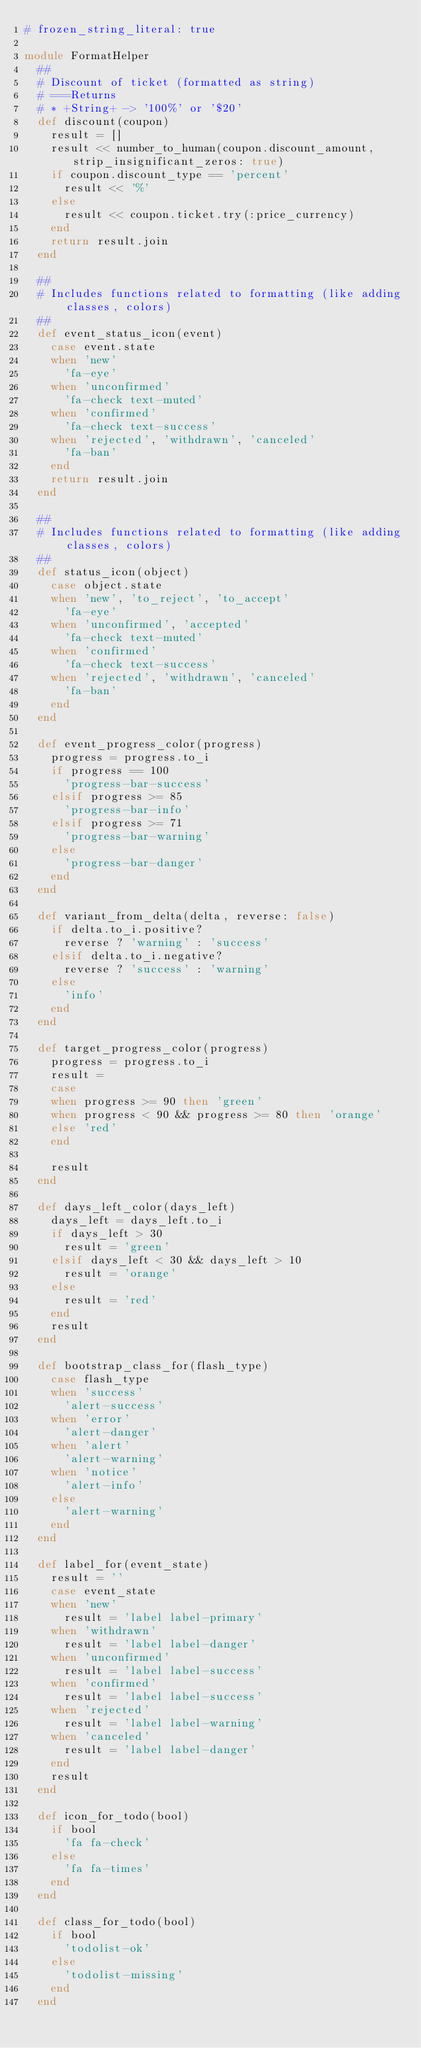<code> <loc_0><loc_0><loc_500><loc_500><_Ruby_># frozen_string_literal: true

module FormatHelper
  ##
  # Discount of ticket (formatted as string)
  # ===Returns
  # * +String+ -> '100%' or '$20'
  def discount(coupon)
    result = []
    result << number_to_human(coupon.discount_amount, strip_insignificant_zeros: true)
    if coupon.discount_type == 'percent'
      result << '%'
    else
      result << coupon.ticket.try(:price_currency)
    end
    return result.join
  end

  ##
  # Includes functions related to formatting (like adding classes, colors)
  ##
  def event_status_icon(event)
    case event.state
    when 'new'
      'fa-eye'
    when 'unconfirmed'
      'fa-check text-muted'
    when 'confirmed'
      'fa-check text-success'
    when 'rejected', 'withdrawn', 'canceled'
      'fa-ban'
    end
    return result.join
  end

  ##
  # Includes functions related to formatting (like adding classes, colors)
  ##
  def status_icon(object)
    case object.state
    when 'new', 'to_reject', 'to_accept'
      'fa-eye'
    when 'unconfirmed', 'accepted'
      'fa-check text-muted'
    when 'confirmed'
      'fa-check text-success'
    when 'rejected', 'withdrawn', 'canceled'
      'fa-ban'
    end
  end

  def event_progress_color(progress)
    progress = progress.to_i
    if progress == 100
      'progress-bar-success'
    elsif progress >= 85
      'progress-bar-info'
    elsif progress >= 71
      'progress-bar-warning'
    else
      'progress-bar-danger'
    end
  end

  def variant_from_delta(delta, reverse: false)
    if delta.to_i.positive?
      reverse ? 'warning' : 'success'
    elsif delta.to_i.negative?
      reverse ? 'success' : 'warning'
    else
      'info'
    end
  end

  def target_progress_color(progress)
    progress = progress.to_i
    result =
    case
    when progress >= 90 then 'green'
    when progress < 90 && progress >= 80 then 'orange'
    else 'red'
    end

    result
  end

  def days_left_color(days_left)
    days_left = days_left.to_i
    if days_left > 30
      result = 'green'
    elsif days_left < 30 && days_left > 10
      result = 'orange'
    else
      result = 'red'
    end
    result
  end

  def bootstrap_class_for(flash_type)
    case flash_type
    when 'success'
      'alert-success'
    when 'error'
      'alert-danger'
    when 'alert'
      'alert-warning'
    when 'notice'
      'alert-info'
    else
      'alert-warning'
    end
  end

  def label_for(event_state)
    result = ''
    case event_state
    when 'new'
      result = 'label label-primary'
    when 'withdrawn'
      result = 'label label-danger'
    when 'unconfirmed'
      result = 'label label-success'
    when 'confirmed'
      result = 'label label-success'
    when 'rejected'
      result = 'label label-warning'
    when 'canceled'
      result = 'label label-danger'
    end
    result
  end

  def icon_for_todo(bool)
    if bool
      'fa fa-check'
    else
      'fa fa-times'
    end
  end

  def class_for_todo(bool)
    if bool
      'todolist-ok'
    else
      'todolist-missing'
    end
  end
</code> 